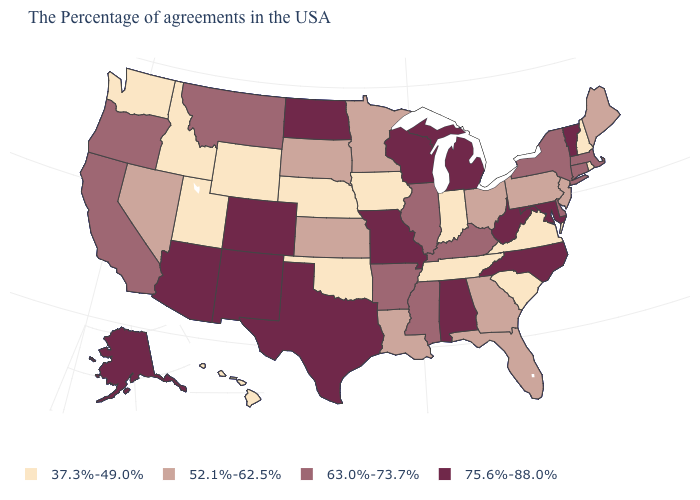Which states have the highest value in the USA?
Answer briefly. Vermont, Maryland, North Carolina, West Virginia, Michigan, Alabama, Wisconsin, Missouri, Texas, North Dakota, Colorado, New Mexico, Arizona, Alaska. What is the value of Maine?
Concise answer only. 52.1%-62.5%. Among the states that border Pennsylvania , which have the highest value?
Keep it brief. Maryland, West Virginia. What is the value of Maine?
Concise answer only. 52.1%-62.5%. Does Alaska have a higher value than Minnesota?
Write a very short answer. Yes. Does Kansas have a lower value than Washington?
Answer briefly. No. Which states hav the highest value in the South?
Concise answer only. Maryland, North Carolina, West Virginia, Alabama, Texas. What is the highest value in states that border New York?
Write a very short answer. 75.6%-88.0%. How many symbols are there in the legend?
Be succinct. 4. What is the value of South Dakota?
Short answer required. 52.1%-62.5%. Is the legend a continuous bar?
Give a very brief answer. No. What is the value of Michigan?
Keep it brief. 75.6%-88.0%. What is the value of Idaho?
Be succinct. 37.3%-49.0%. What is the value of South Dakota?
Keep it brief. 52.1%-62.5%. What is the value of Colorado?
Be succinct. 75.6%-88.0%. 